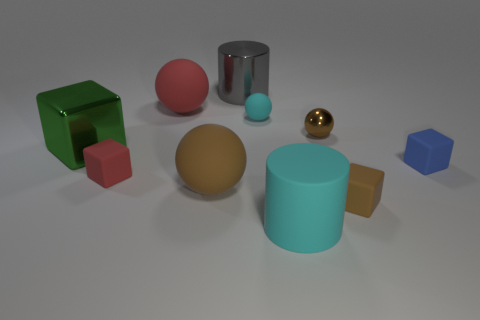There is a large matte thing that is in front of the big brown object; is its shape the same as the large metal object behind the small rubber sphere?
Give a very brief answer. Yes. There is a big thing that is the same shape as the tiny brown rubber thing; what color is it?
Give a very brief answer. Green. What material is the tiny red thing?
Ensure brevity in your answer.  Rubber. Are there any other things that are the same color as the shiny cylinder?
Your answer should be very brief. No. Does the large cyan matte object have the same shape as the large gray metal thing?
Offer a terse response. Yes. What size is the metal sphere right of the large metallic object that is in front of the large cylinder behind the big block?
Make the answer very short. Small. How many other objects are there of the same material as the blue cube?
Provide a succinct answer. 6. What color is the big rubber sphere that is in front of the red matte cube?
Give a very brief answer. Brown. What is the cylinder to the left of the matte ball to the right of the cylinder that is behind the big green object made of?
Your answer should be very brief. Metal. Is there a brown thing of the same shape as the green metal thing?
Ensure brevity in your answer.  Yes. 